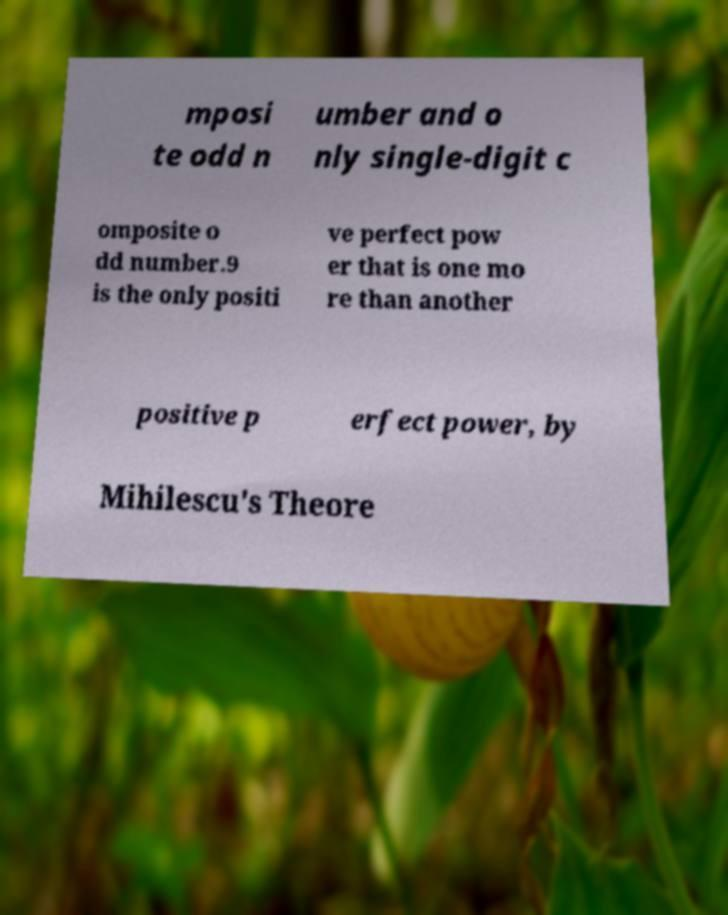I need the written content from this picture converted into text. Can you do that? mposi te odd n umber and o nly single-digit c omposite o dd number.9 is the only positi ve perfect pow er that is one mo re than another positive p erfect power, by Mihilescu's Theore 